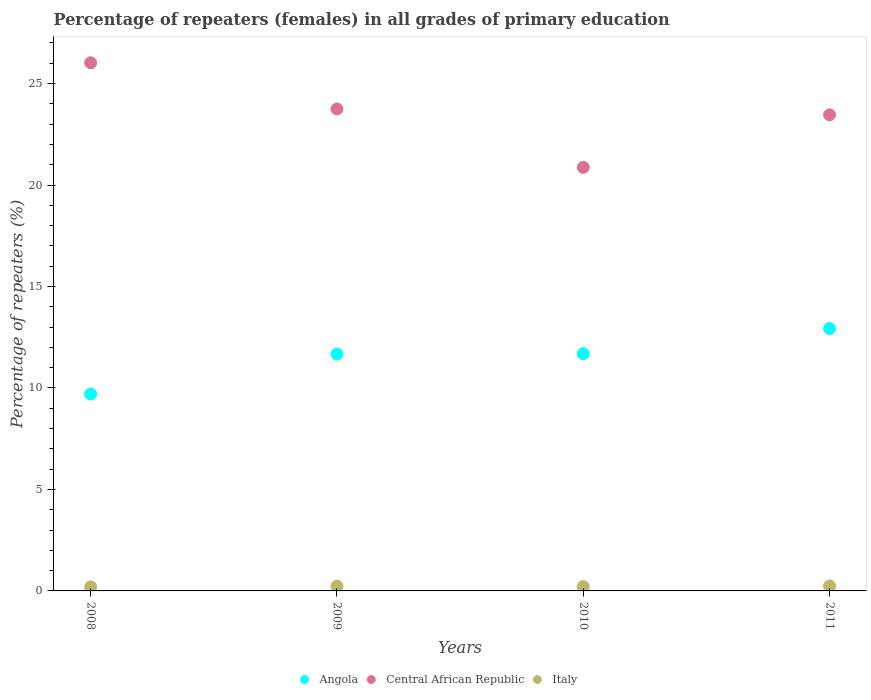How many different coloured dotlines are there?
Your response must be concise. 3. Is the number of dotlines equal to the number of legend labels?
Provide a succinct answer. Yes. What is the percentage of repeaters (females) in Angola in 2011?
Provide a short and direct response. 12.93. Across all years, what is the maximum percentage of repeaters (females) in Angola?
Make the answer very short. 12.93. Across all years, what is the minimum percentage of repeaters (females) in Italy?
Offer a very short reply. 0.2. In which year was the percentage of repeaters (females) in Angola minimum?
Provide a short and direct response. 2008. What is the total percentage of repeaters (females) in Italy in the graph?
Your response must be concise. 0.89. What is the difference between the percentage of repeaters (females) in Italy in 2009 and that in 2011?
Provide a succinct answer. -0.01. What is the difference between the percentage of repeaters (females) in Italy in 2009 and the percentage of repeaters (females) in Central African Republic in 2008?
Give a very brief answer. -25.79. What is the average percentage of repeaters (females) in Italy per year?
Your answer should be compact. 0.22. In the year 2009, what is the difference between the percentage of repeaters (females) in Angola and percentage of repeaters (females) in Italy?
Ensure brevity in your answer.  11.44. What is the ratio of the percentage of repeaters (females) in Italy in 2009 to that in 2011?
Your response must be concise. 0.95. Is the difference between the percentage of repeaters (females) in Angola in 2009 and 2010 greater than the difference between the percentage of repeaters (females) in Italy in 2009 and 2010?
Give a very brief answer. No. What is the difference between the highest and the second highest percentage of repeaters (females) in Angola?
Provide a succinct answer. 1.24. What is the difference between the highest and the lowest percentage of repeaters (females) in Italy?
Your response must be concise. 0.04. Is the sum of the percentage of repeaters (females) in Angola in 2008 and 2009 greater than the maximum percentage of repeaters (females) in Central African Republic across all years?
Offer a terse response. No. Is it the case that in every year, the sum of the percentage of repeaters (females) in Central African Republic and percentage of repeaters (females) in Italy  is greater than the percentage of repeaters (females) in Angola?
Provide a short and direct response. Yes. Does the percentage of repeaters (females) in Angola monotonically increase over the years?
Your answer should be very brief. Yes. Is the percentage of repeaters (females) in Angola strictly greater than the percentage of repeaters (females) in Central African Republic over the years?
Ensure brevity in your answer.  No. How many dotlines are there?
Offer a very short reply. 3. How many years are there in the graph?
Your answer should be very brief. 4. Does the graph contain any zero values?
Provide a short and direct response. No. Does the graph contain grids?
Provide a succinct answer. No. How many legend labels are there?
Ensure brevity in your answer.  3. What is the title of the graph?
Your answer should be very brief. Percentage of repeaters (females) in all grades of primary education. What is the label or title of the Y-axis?
Ensure brevity in your answer.  Percentage of repeaters (%). What is the Percentage of repeaters (%) in Angola in 2008?
Your answer should be very brief. 9.7. What is the Percentage of repeaters (%) in Central African Republic in 2008?
Offer a terse response. 26.02. What is the Percentage of repeaters (%) in Italy in 2008?
Provide a short and direct response. 0.2. What is the Percentage of repeaters (%) of Angola in 2009?
Ensure brevity in your answer.  11.67. What is the Percentage of repeaters (%) of Central African Republic in 2009?
Offer a very short reply. 23.75. What is the Percentage of repeaters (%) of Italy in 2009?
Offer a very short reply. 0.23. What is the Percentage of repeaters (%) of Angola in 2010?
Make the answer very short. 11.69. What is the Percentage of repeaters (%) in Central African Republic in 2010?
Your response must be concise. 20.87. What is the Percentage of repeaters (%) of Italy in 2010?
Make the answer very short. 0.21. What is the Percentage of repeaters (%) of Angola in 2011?
Your answer should be very brief. 12.93. What is the Percentage of repeaters (%) of Central African Republic in 2011?
Provide a succinct answer. 23.46. What is the Percentage of repeaters (%) in Italy in 2011?
Keep it short and to the point. 0.24. Across all years, what is the maximum Percentage of repeaters (%) in Angola?
Provide a short and direct response. 12.93. Across all years, what is the maximum Percentage of repeaters (%) of Central African Republic?
Provide a short and direct response. 26.02. Across all years, what is the maximum Percentage of repeaters (%) in Italy?
Keep it short and to the point. 0.24. Across all years, what is the minimum Percentage of repeaters (%) in Angola?
Provide a succinct answer. 9.7. Across all years, what is the minimum Percentage of repeaters (%) of Central African Republic?
Offer a terse response. 20.87. Across all years, what is the minimum Percentage of repeaters (%) in Italy?
Provide a succinct answer. 0.2. What is the total Percentage of repeaters (%) in Angola in the graph?
Offer a terse response. 45.99. What is the total Percentage of repeaters (%) in Central African Republic in the graph?
Give a very brief answer. 94.1. What is the total Percentage of repeaters (%) of Italy in the graph?
Keep it short and to the point. 0.89. What is the difference between the Percentage of repeaters (%) in Angola in 2008 and that in 2009?
Provide a succinct answer. -1.97. What is the difference between the Percentage of repeaters (%) in Central African Republic in 2008 and that in 2009?
Make the answer very short. 2.28. What is the difference between the Percentage of repeaters (%) of Italy in 2008 and that in 2009?
Give a very brief answer. -0.03. What is the difference between the Percentage of repeaters (%) of Angola in 2008 and that in 2010?
Offer a very short reply. -1.99. What is the difference between the Percentage of repeaters (%) in Central African Republic in 2008 and that in 2010?
Keep it short and to the point. 5.15. What is the difference between the Percentage of repeaters (%) in Italy in 2008 and that in 2010?
Offer a terse response. -0.02. What is the difference between the Percentage of repeaters (%) in Angola in 2008 and that in 2011?
Your answer should be very brief. -3.23. What is the difference between the Percentage of repeaters (%) in Central African Republic in 2008 and that in 2011?
Ensure brevity in your answer.  2.56. What is the difference between the Percentage of repeaters (%) in Italy in 2008 and that in 2011?
Provide a short and direct response. -0.04. What is the difference between the Percentage of repeaters (%) of Angola in 2009 and that in 2010?
Make the answer very short. -0.02. What is the difference between the Percentage of repeaters (%) of Central African Republic in 2009 and that in 2010?
Offer a very short reply. 2.88. What is the difference between the Percentage of repeaters (%) of Italy in 2009 and that in 2010?
Ensure brevity in your answer.  0.02. What is the difference between the Percentage of repeaters (%) of Angola in 2009 and that in 2011?
Keep it short and to the point. -1.26. What is the difference between the Percentage of repeaters (%) in Central African Republic in 2009 and that in 2011?
Your answer should be compact. 0.29. What is the difference between the Percentage of repeaters (%) of Italy in 2009 and that in 2011?
Keep it short and to the point. -0.01. What is the difference between the Percentage of repeaters (%) of Angola in 2010 and that in 2011?
Offer a terse response. -1.24. What is the difference between the Percentage of repeaters (%) of Central African Republic in 2010 and that in 2011?
Your answer should be very brief. -2.59. What is the difference between the Percentage of repeaters (%) of Italy in 2010 and that in 2011?
Your answer should be very brief. -0.03. What is the difference between the Percentage of repeaters (%) in Angola in 2008 and the Percentage of repeaters (%) in Central African Republic in 2009?
Offer a terse response. -14.05. What is the difference between the Percentage of repeaters (%) of Angola in 2008 and the Percentage of repeaters (%) of Italy in 2009?
Provide a succinct answer. 9.47. What is the difference between the Percentage of repeaters (%) in Central African Republic in 2008 and the Percentage of repeaters (%) in Italy in 2009?
Provide a short and direct response. 25.79. What is the difference between the Percentage of repeaters (%) in Angola in 2008 and the Percentage of repeaters (%) in Central African Republic in 2010?
Your response must be concise. -11.17. What is the difference between the Percentage of repeaters (%) in Angola in 2008 and the Percentage of repeaters (%) in Italy in 2010?
Give a very brief answer. 9.49. What is the difference between the Percentage of repeaters (%) of Central African Republic in 2008 and the Percentage of repeaters (%) of Italy in 2010?
Make the answer very short. 25.81. What is the difference between the Percentage of repeaters (%) in Angola in 2008 and the Percentage of repeaters (%) in Central African Republic in 2011?
Give a very brief answer. -13.76. What is the difference between the Percentage of repeaters (%) of Angola in 2008 and the Percentage of repeaters (%) of Italy in 2011?
Offer a terse response. 9.46. What is the difference between the Percentage of repeaters (%) in Central African Republic in 2008 and the Percentage of repeaters (%) in Italy in 2011?
Make the answer very short. 25.78. What is the difference between the Percentage of repeaters (%) of Angola in 2009 and the Percentage of repeaters (%) of Central African Republic in 2010?
Your answer should be very brief. -9.2. What is the difference between the Percentage of repeaters (%) of Angola in 2009 and the Percentage of repeaters (%) of Italy in 2010?
Your answer should be compact. 11.45. What is the difference between the Percentage of repeaters (%) in Central African Republic in 2009 and the Percentage of repeaters (%) in Italy in 2010?
Provide a succinct answer. 23.53. What is the difference between the Percentage of repeaters (%) in Angola in 2009 and the Percentage of repeaters (%) in Central African Republic in 2011?
Give a very brief answer. -11.79. What is the difference between the Percentage of repeaters (%) in Angola in 2009 and the Percentage of repeaters (%) in Italy in 2011?
Give a very brief answer. 11.42. What is the difference between the Percentage of repeaters (%) in Central African Republic in 2009 and the Percentage of repeaters (%) in Italy in 2011?
Ensure brevity in your answer.  23.51. What is the difference between the Percentage of repeaters (%) in Angola in 2010 and the Percentage of repeaters (%) in Central African Republic in 2011?
Give a very brief answer. -11.77. What is the difference between the Percentage of repeaters (%) of Angola in 2010 and the Percentage of repeaters (%) of Italy in 2011?
Your answer should be compact. 11.45. What is the difference between the Percentage of repeaters (%) of Central African Republic in 2010 and the Percentage of repeaters (%) of Italy in 2011?
Keep it short and to the point. 20.63. What is the average Percentage of repeaters (%) in Angola per year?
Offer a terse response. 11.5. What is the average Percentage of repeaters (%) of Central African Republic per year?
Offer a very short reply. 23.53. What is the average Percentage of repeaters (%) in Italy per year?
Make the answer very short. 0.22. In the year 2008, what is the difference between the Percentage of repeaters (%) in Angola and Percentage of repeaters (%) in Central African Republic?
Offer a terse response. -16.32. In the year 2008, what is the difference between the Percentage of repeaters (%) of Angola and Percentage of repeaters (%) of Italy?
Offer a terse response. 9.5. In the year 2008, what is the difference between the Percentage of repeaters (%) of Central African Republic and Percentage of repeaters (%) of Italy?
Ensure brevity in your answer.  25.83. In the year 2009, what is the difference between the Percentage of repeaters (%) in Angola and Percentage of repeaters (%) in Central African Republic?
Your answer should be compact. -12.08. In the year 2009, what is the difference between the Percentage of repeaters (%) in Angola and Percentage of repeaters (%) in Italy?
Your answer should be compact. 11.44. In the year 2009, what is the difference between the Percentage of repeaters (%) in Central African Republic and Percentage of repeaters (%) in Italy?
Offer a very short reply. 23.52. In the year 2010, what is the difference between the Percentage of repeaters (%) of Angola and Percentage of repeaters (%) of Central African Republic?
Provide a succinct answer. -9.18. In the year 2010, what is the difference between the Percentage of repeaters (%) of Angola and Percentage of repeaters (%) of Italy?
Keep it short and to the point. 11.48. In the year 2010, what is the difference between the Percentage of repeaters (%) in Central African Republic and Percentage of repeaters (%) in Italy?
Provide a succinct answer. 20.66. In the year 2011, what is the difference between the Percentage of repeaters (%) in Angola and Percentage of repeaters (%) in Central African Republic?
Ensure brevity in your answer.  -10.53. In the year 2011, what is the difference between the Percentage of repeaters (%) in Angola and Percentage of repeaters (%) in Italy?
Make the answer very short. 12.69. In the year 2011, what is the difference between the Percentage of repeaters (%) of Central African Republic and Percentage of repeaters (%) of Italy?
Provide a short and direct response. 23.22. What is the ratio of the Percentage of repeaters (%) in Angola in 2008 to that in 2009?
Ensure brevity in your answer.  0.83. What is the ratio of the Percentage of repeaters (%) of Central African Republic in 2008 to that in 2009?
Give a very brief answer. 1.1. What is the ratio of the Percentage of repeaters (%) of Italy in 2008 to that in 2009?
Offer a very short reply. 0.86. What is the ratio of the Percentage of repeaters (%) in Angola in 2008 to that in 2010?
Give a very brief answer. 0.83. What is the ratio of the Percentage of repeaters (%) of Central African Republic in 2008 to that in 2010?
Offer a very short reply. 1.25. What is the ratio of the Percentage of repeaters (%) of Italy in 2008 to that in 2010?
Give a very brief answer. 0.93. What is the ratio of the Percentage of repeaters (%) in Angola in 2008 to that in 2011?
Your answer should be compact. 0.75. What is the ratio of the Percentage of repeaters (%) in Central African Republic in 2008 to that in 2011?
Offer a terse response. 1.11. What is the ratio of the Percentage of repeaters (%) in Italy in 2008 to that in 2011?
Ensure brevity in your answer.  0.82. What is the ratio of the Percentage of repeaters (%) in Central African Republic in 2009 to that in 2010?
Your answer should be compact. 1.14. What is the ratio of the Percentage of repeaters (%) of Italy in 2009 to that in 2010?
Keep it short and to the point. 1.08. What is the ratio of the Percentage of repeaters (%) of Angola in 2009 to that in 2011?
Your response must be concise. 0.9. What is the ratio of the Percentage of repeaters (%) in Central African Republic in 2009 to that in 2011?
Offer a terse response. 1.01. What is the ratio of the Percentage of repeaters (%) of Italy in 2009 to that in 2011?
Offer a terse response. 0.95. What is the ratio of the Percentage of repeaters (%) in Angola in 2010 to that in 2011?
Your answer should be very brief. 0.9. What is the ratio of the Percentage of repeaters (%) of Central African Republic in 2010 to that in 2011?
Give a very brief answer. 0.89. What is the ratio of the Percentage of repeaters (%) in Italy in 2010 to that in 2011?
Give a very brief answer. 0.88. What is the difference between the highest and the second highest Percentage of repeaters (%) of Angola?
Offer a very short reply. 1.24. What is the difference between the highest and the second highest Percentage of repeaters (%) of Central African Republic?
Ensure brevity in your answer.  2.28. What is the difference between the highest and the second highest Percentage of repeaters (%) in Italy?
Your answer should be compact. 0.01. What is the difference between the highest and the lowest Percentage of repeaters (%) of Angola?
Make the answer very short. 3.23. What is the difference between the highest and the lowest Percentage of repeaters (%) in Central African Republic?
Provide a short and direct response. 5.15. What is the difference between the highest and the lowest Percentage of repeaters (%) in Italy?
Offer a terse response. 0.04. 